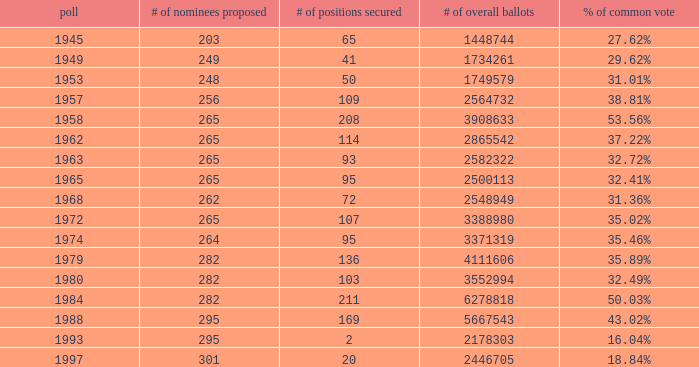How many times was the # of total votes 2582322? 1.0. 